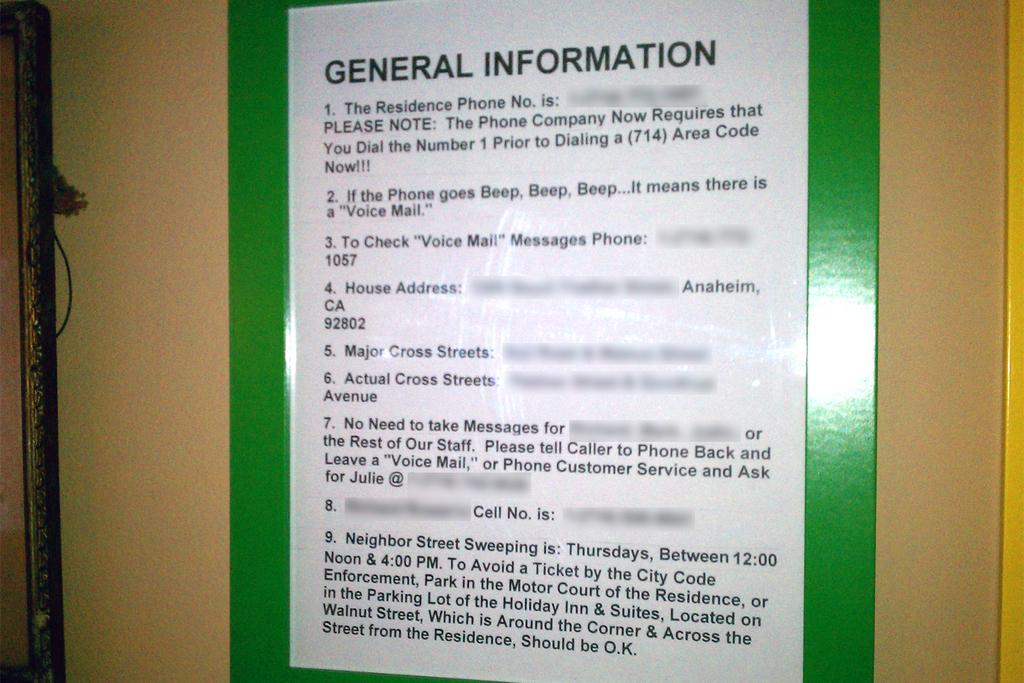<image>
Create a compact narrative representing the image presented. a sign for General Information is on a green background tacked on a wall 